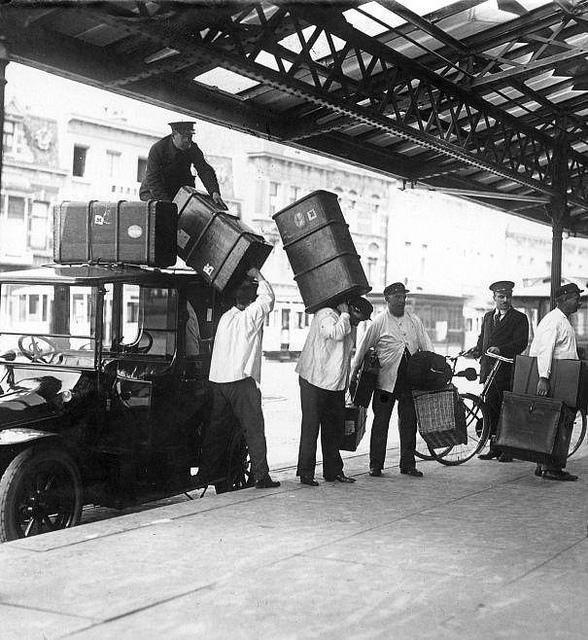How many suitcases can you see?
Give a very brief answer. 6. How many bicycles are there?
Give a very brief answer. 1. How many people can be seen?
Give a very brief answer. 6. 